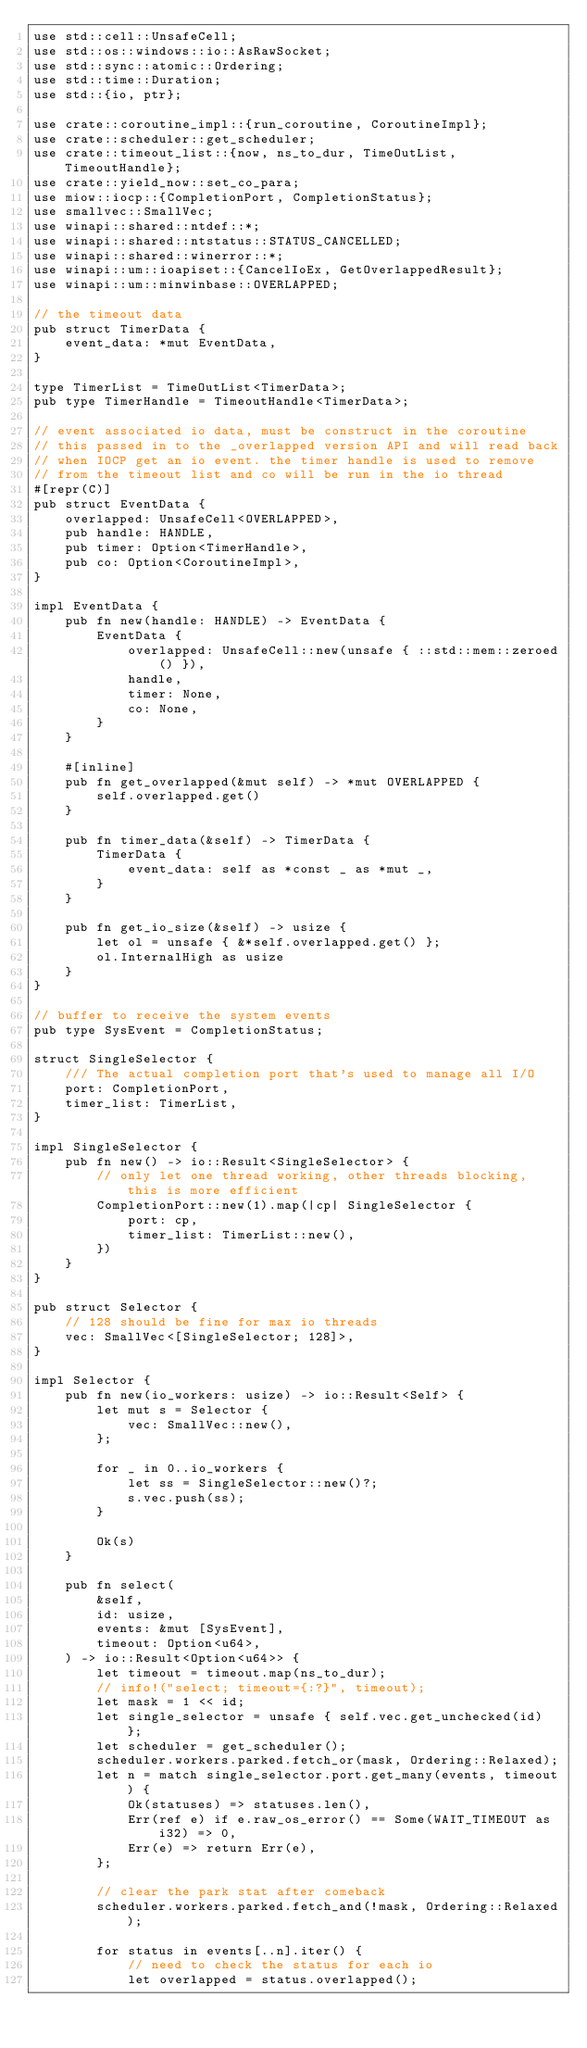Convert code to text. <code><loc_0><loc_0><loc_500><loc_500><_Rust_>use std::cell::UnsafeCell;
use std::os::windows::io::AsRawSocket;
use std::sync::atomic::Ordering;
use std::time::Duration;
use std::{io, ptr};

use crate::coroutine_impl::{run_coroutine, CoroutineImpl};
use crate::scheduler::get_scheduler;
use crate::timeout_list::{now, ns_to_dur, TimeOutList, TimeoutHandle};
use crate::yield_now::set_co_para;
use miow::iocp::{CompletionPort, CompletionStatus};
use smallvec::SmallVec;
use winapi::shared::ntdef::*;
use winapi::shared::ntstatus::STATUS_CANCELLED;
use winapi::shared::winerror::*;
use winapi::um::ioapiset::{CancelIoEx, GetOverlappedResult};
use winapi::um::minwinbase::OVERLAPPED;

// the timeout data
pub struct TimerData {
    event_data: *mut EventData,
}

type TimerList = TimeOutList<TimerData>;
pub type TimerHandle = TimeoutHandle<TimerData>;

// event associated io data, must be construct in the coroutine
// this passed in to the _overlapped version API and will read back
// when IOCP get an io event. the timer handle is used to remove
// from the timeout list and co will be run in the io thread
#[repr(C)]
pub struct EventData {
    overlapped: UnsafeCell<OVERLAPPED>,
    pub handle: HANDLE,
    pub timer: Option<TimerHandle>,
    pub co: Option<CoroutineImpl>,
}

impl EventData {
    pub fn new(handle: HANDLE) -> EventData {
        EventData {
            overlapped: UnsafeCell::new(unsafe { ::std::mem::zeroed() }),
            handle,
            timer: None,
            co: None,
        }
    }

    #[inline]
    pub fn get_overlapped(&mut self) -> *mut OVERLAPPED {
        self.overlapped.get()
    }

    pub fn timer_data(&self) -> TimerData {
        TimerData {
            event_data: self as *const _ as *mut _,
        }
    }

    pub fn get_io_size(&self) -> usize {
        let ol = unsafe { &*self.overlapped.get() };
        ol.InternalHigh as usize
    }
}

// buffer to receive the system events
pub type SysEvent = CompletionStatus;

struct SingleSelector {
    /// The actual completion port that's used to manage all I/O
    port: CompletionPort,
    timer_list: TimerList,
}

impl SingleSelector {
    pub fn new() -> io::Result<SingleSelector> {
        // only let one thread working, other threads blocking, this is more efficient
        CompletionPort::new(1).map(|cp| SingleSelector {
            port: cp,
            timer_list: TimerList::new(),
        })
    }
}

pub struct Selector {
    // 128 should be fine for max io threads
    vec: SmallVec<[SingleSelector; 128]>,
}

impl Selector {
    pub fn new(io_workers: usize) -> io::Result<Self> {
        let mut s = Selector {
            vec: SmallVec::new(),
        };

        for _ in 0..io_workers {
            let ss = SingleSelector::new()?;
            s.vec.push(ss);
        }

        Ok(s)
    }

    pub fn select(
        &self,
        id: usize,
        events: &mut [SysEvent],
        timeout: Option<u64>,
    ) -> io::Result<Option<u64>> {
        let timeout = timeout.map(ns_to_dur);
        // info!("select; timeout={:?}", timeout);
        let mask = 1 << id;
        let single_selector = unsafe { self.vec.get_unchecked(id) };
        let scheduler = get_scheduler();
        scheduler.workers.parked.fetch_or(mask, Ordering::Relaxed);
        let n = match single_selector.port.get_many(events, timeout) {
            Ok(statuses) => statuses.len(),
            Err(ref e) if e.raw_os_error() == Some(WAIT_TIMEOUT as i32) => 0,
            Err(e) => return Err(e),
        };

        // clear the park stat after comeback
        scheduler.workers.parked.fetch_and(!mask, Ordering::Relaxed);

        for status in events[..n].iter() {
            // need to check the status for each io
            let overlapped = status.overlapped();</code> 